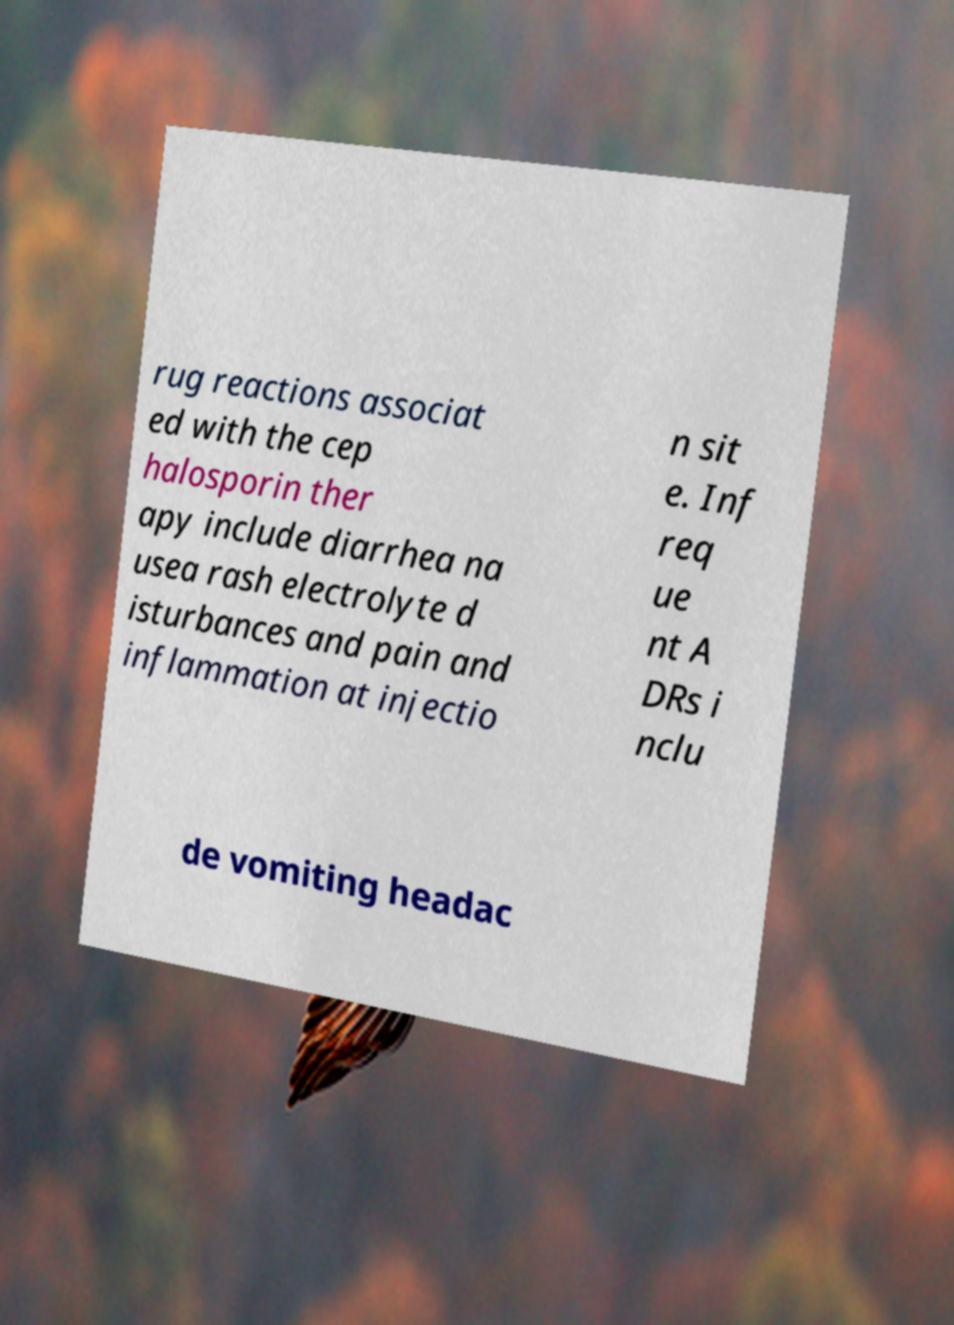What messages or text are displayed in this image? I need them in a readable, typed format. rug reactions associat ed with the cep halosporin ther apy include diarrhea na usea rash electrolyte d isturbances and pain and inflammation at injectio n sit e. Inf req ue nt A DRs i nclu de vomiting headac 